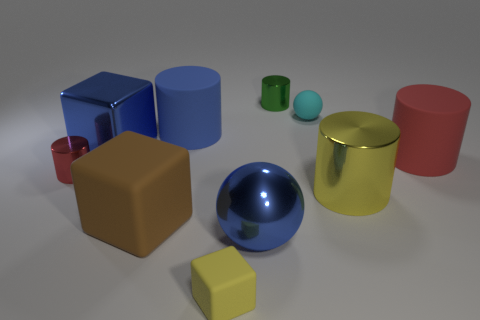What material do the objects seem to be made of? The objects in the image give the impression of various materials. The sphere and the blocks have a reflective surface, suggesting a metallic or glossy finish. Meanwhile, the cylinders have a less reflective, possibly matte finish that might indicate a plastic or painted surface. 